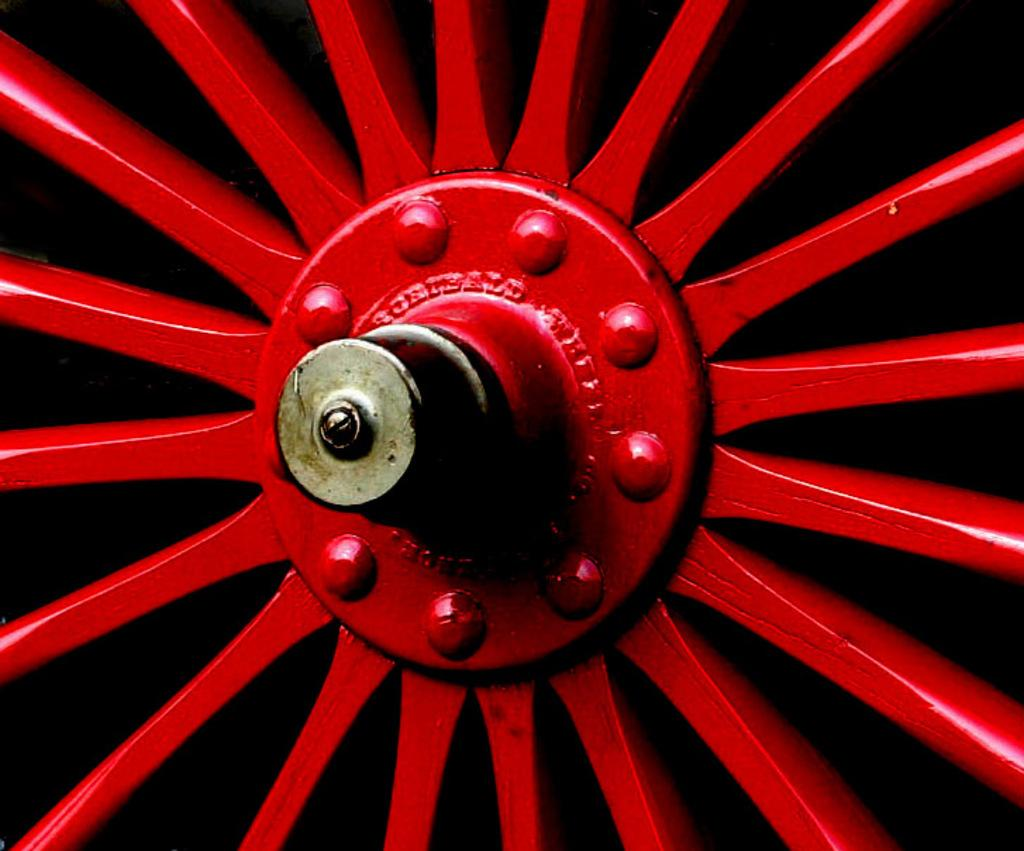What is the main object in the image? There is a machine in the image. What color is the machine? The machine is red in color. What additional details can be observed on the machine? There are bolts on the machine. What type of orange is being used to start the machine in the image? There is no orange present in the image, and the machine does not require an orange to start. 